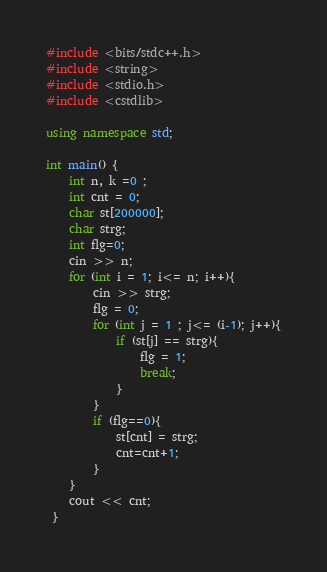Convert code to text. <code><loc_0><loc_0><loc_500><loc_500><_C++_>#include <bits/stdc++.h>
#include <string>
#include <stdio.h>
#include <cstdlib>

using namespace std;

int main() {
    int n, k =0 ;
    int cnt = 0;
    char st[200000];
    char strg;
    int flg=0;
    cin >> n;
    for (int i = 1; i<= n; i++){
        cin >> strg; 
        flg = 0;
        for (int j = 1 ; j<= (i-1); j++){
            if (st[j] == strg){
                flg = 1;
                break;
            }
        }
        if (flg==0){
            st[cnt] = strg;
            cnt=cnt+1;
        }
    }
    cout << cnt;
 }
</code> 